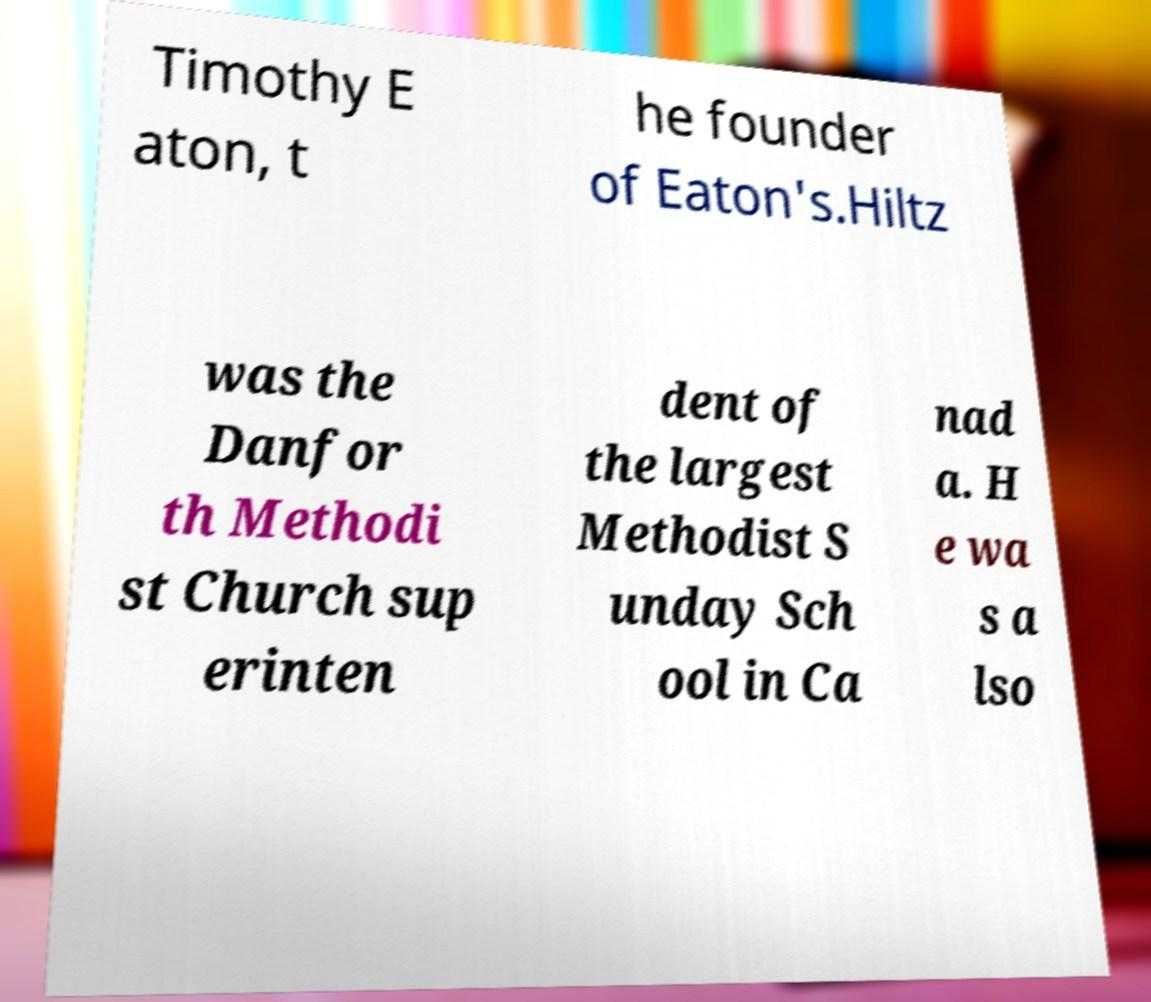Can you read and provide the text displayed in the image?This photo seems to have some interesting text. Can you extract and type it out for me? Timothy E aton, t he founder of Eaton's.Hiltz was the Danfor th Methodi st Church sup erinten dent of the largest Methodist S unday Sch ool in Ca nad a. H e wa s a lso 